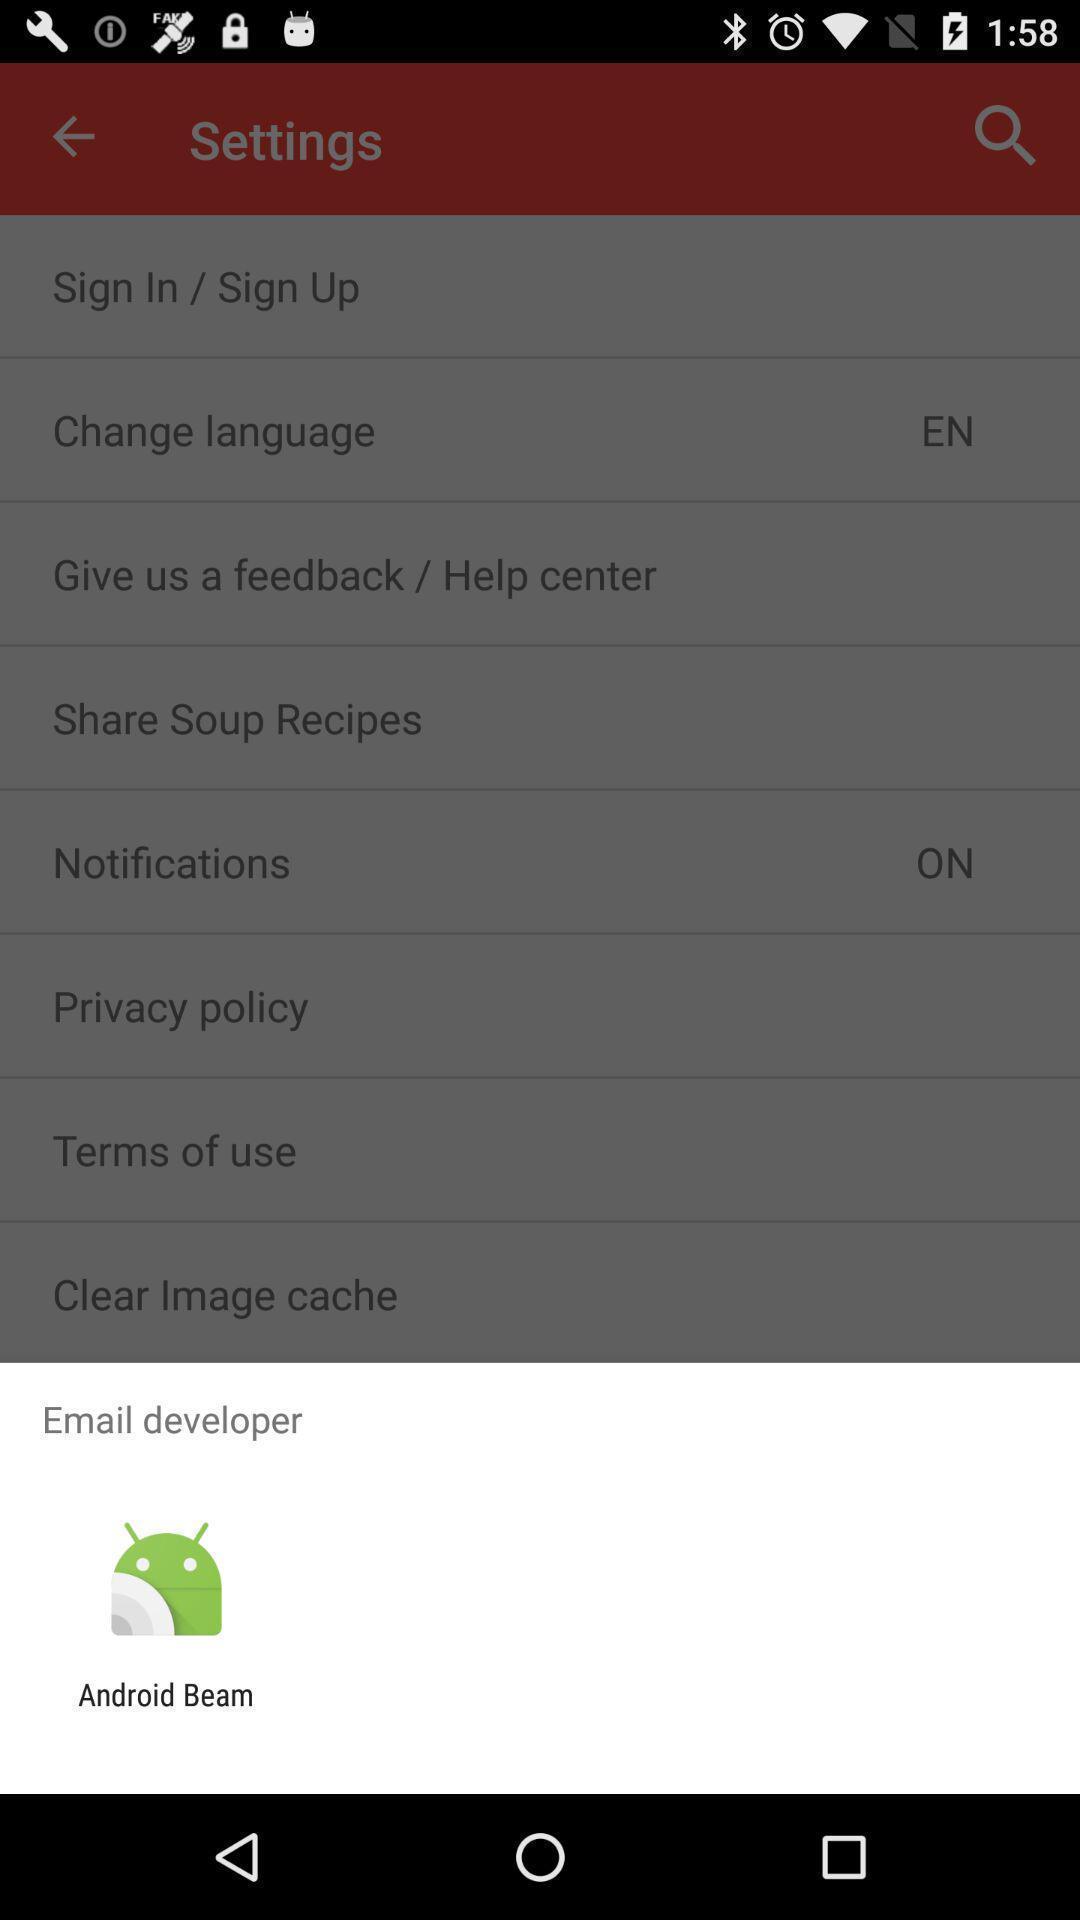Summarize the main components in this picture. Widget showing a data transferring app. 